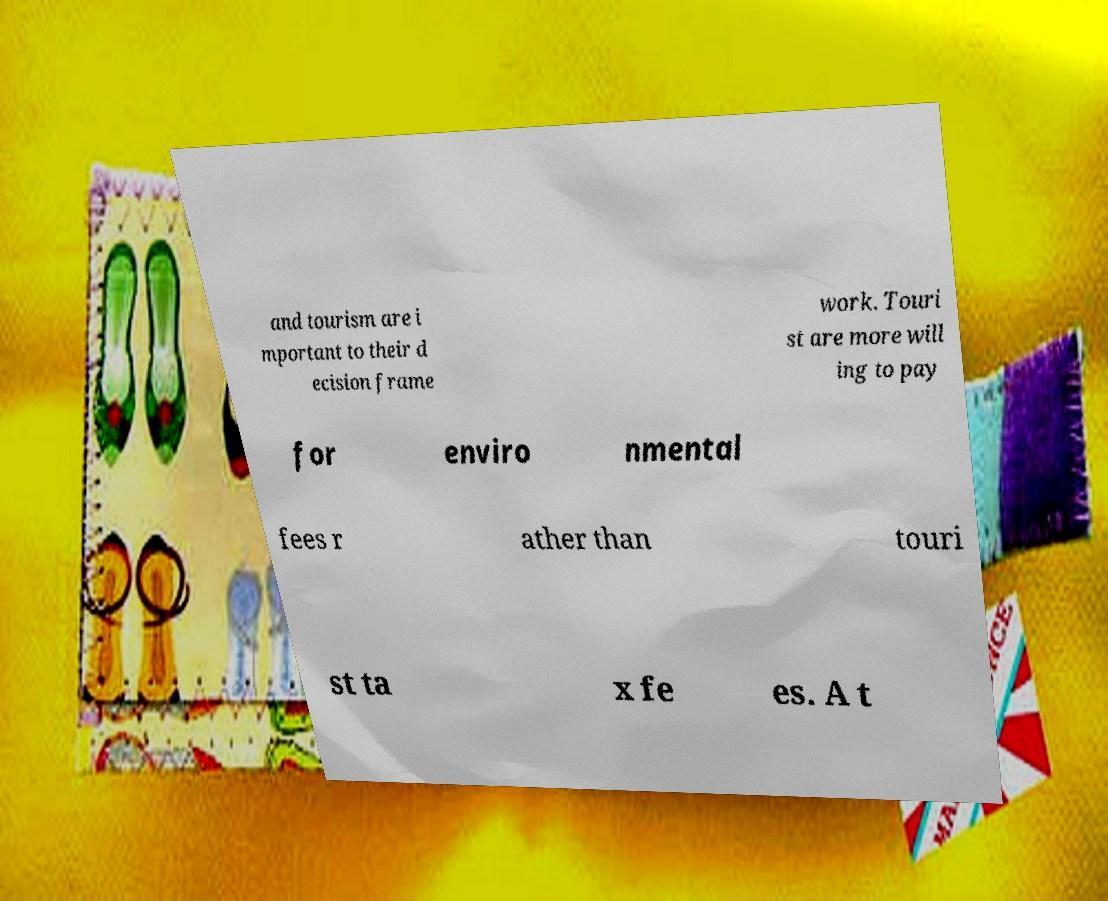For documentation purposes, I need the text within this image transcribed. Could you provide that? and tourism are i mportant to their d ecision frame work. Touri st are more will ing to pay for enviro nmental fees r ather than touri st ta x fe es. A t 